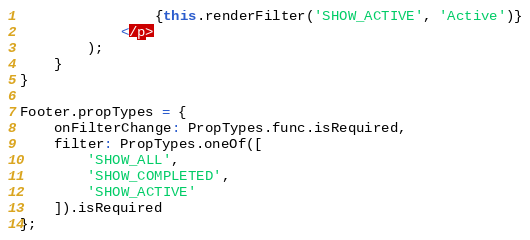Convert code to text. <code><loc_0><loc_0><loc_500><loc_500><_JavaScript_>                {this.renderFilter('SHOW_ACTIVE', 'Active')}
            </p>
        );
    }
}

Footer.propTypes = {
    onFilterChange: PropTypes.func.isRequired,
    filter: PropTypes.oneOf([
        'SHOW_ALL',
        'SHOW_COMPLETED',
        'SHOW_ACTIVE'
    ]).isRequired
};</code> 